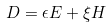Convert formula to latex. <formula><loc_0><loc_0><loc_500><loc_500>D = \epsilon E + \xi H</formula> 